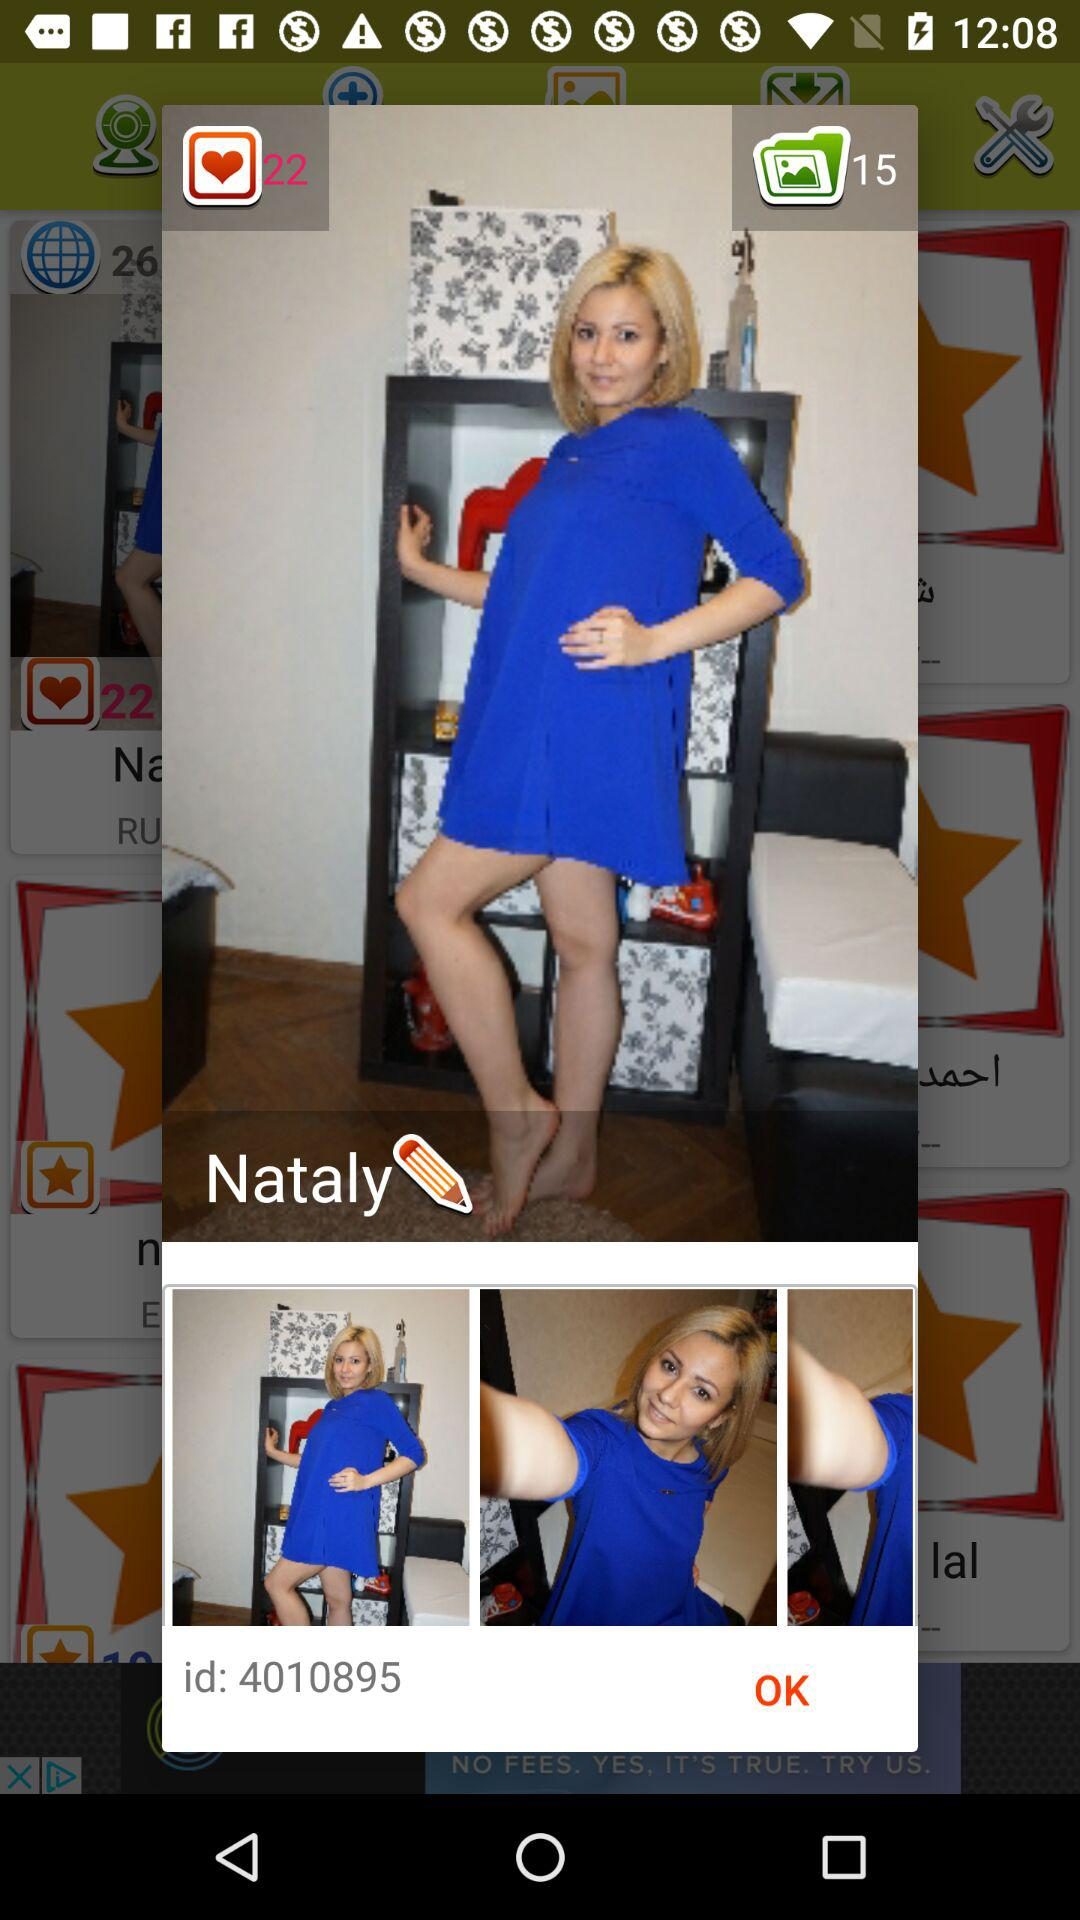How many likes did the picture get? The picture got 22 likes. 